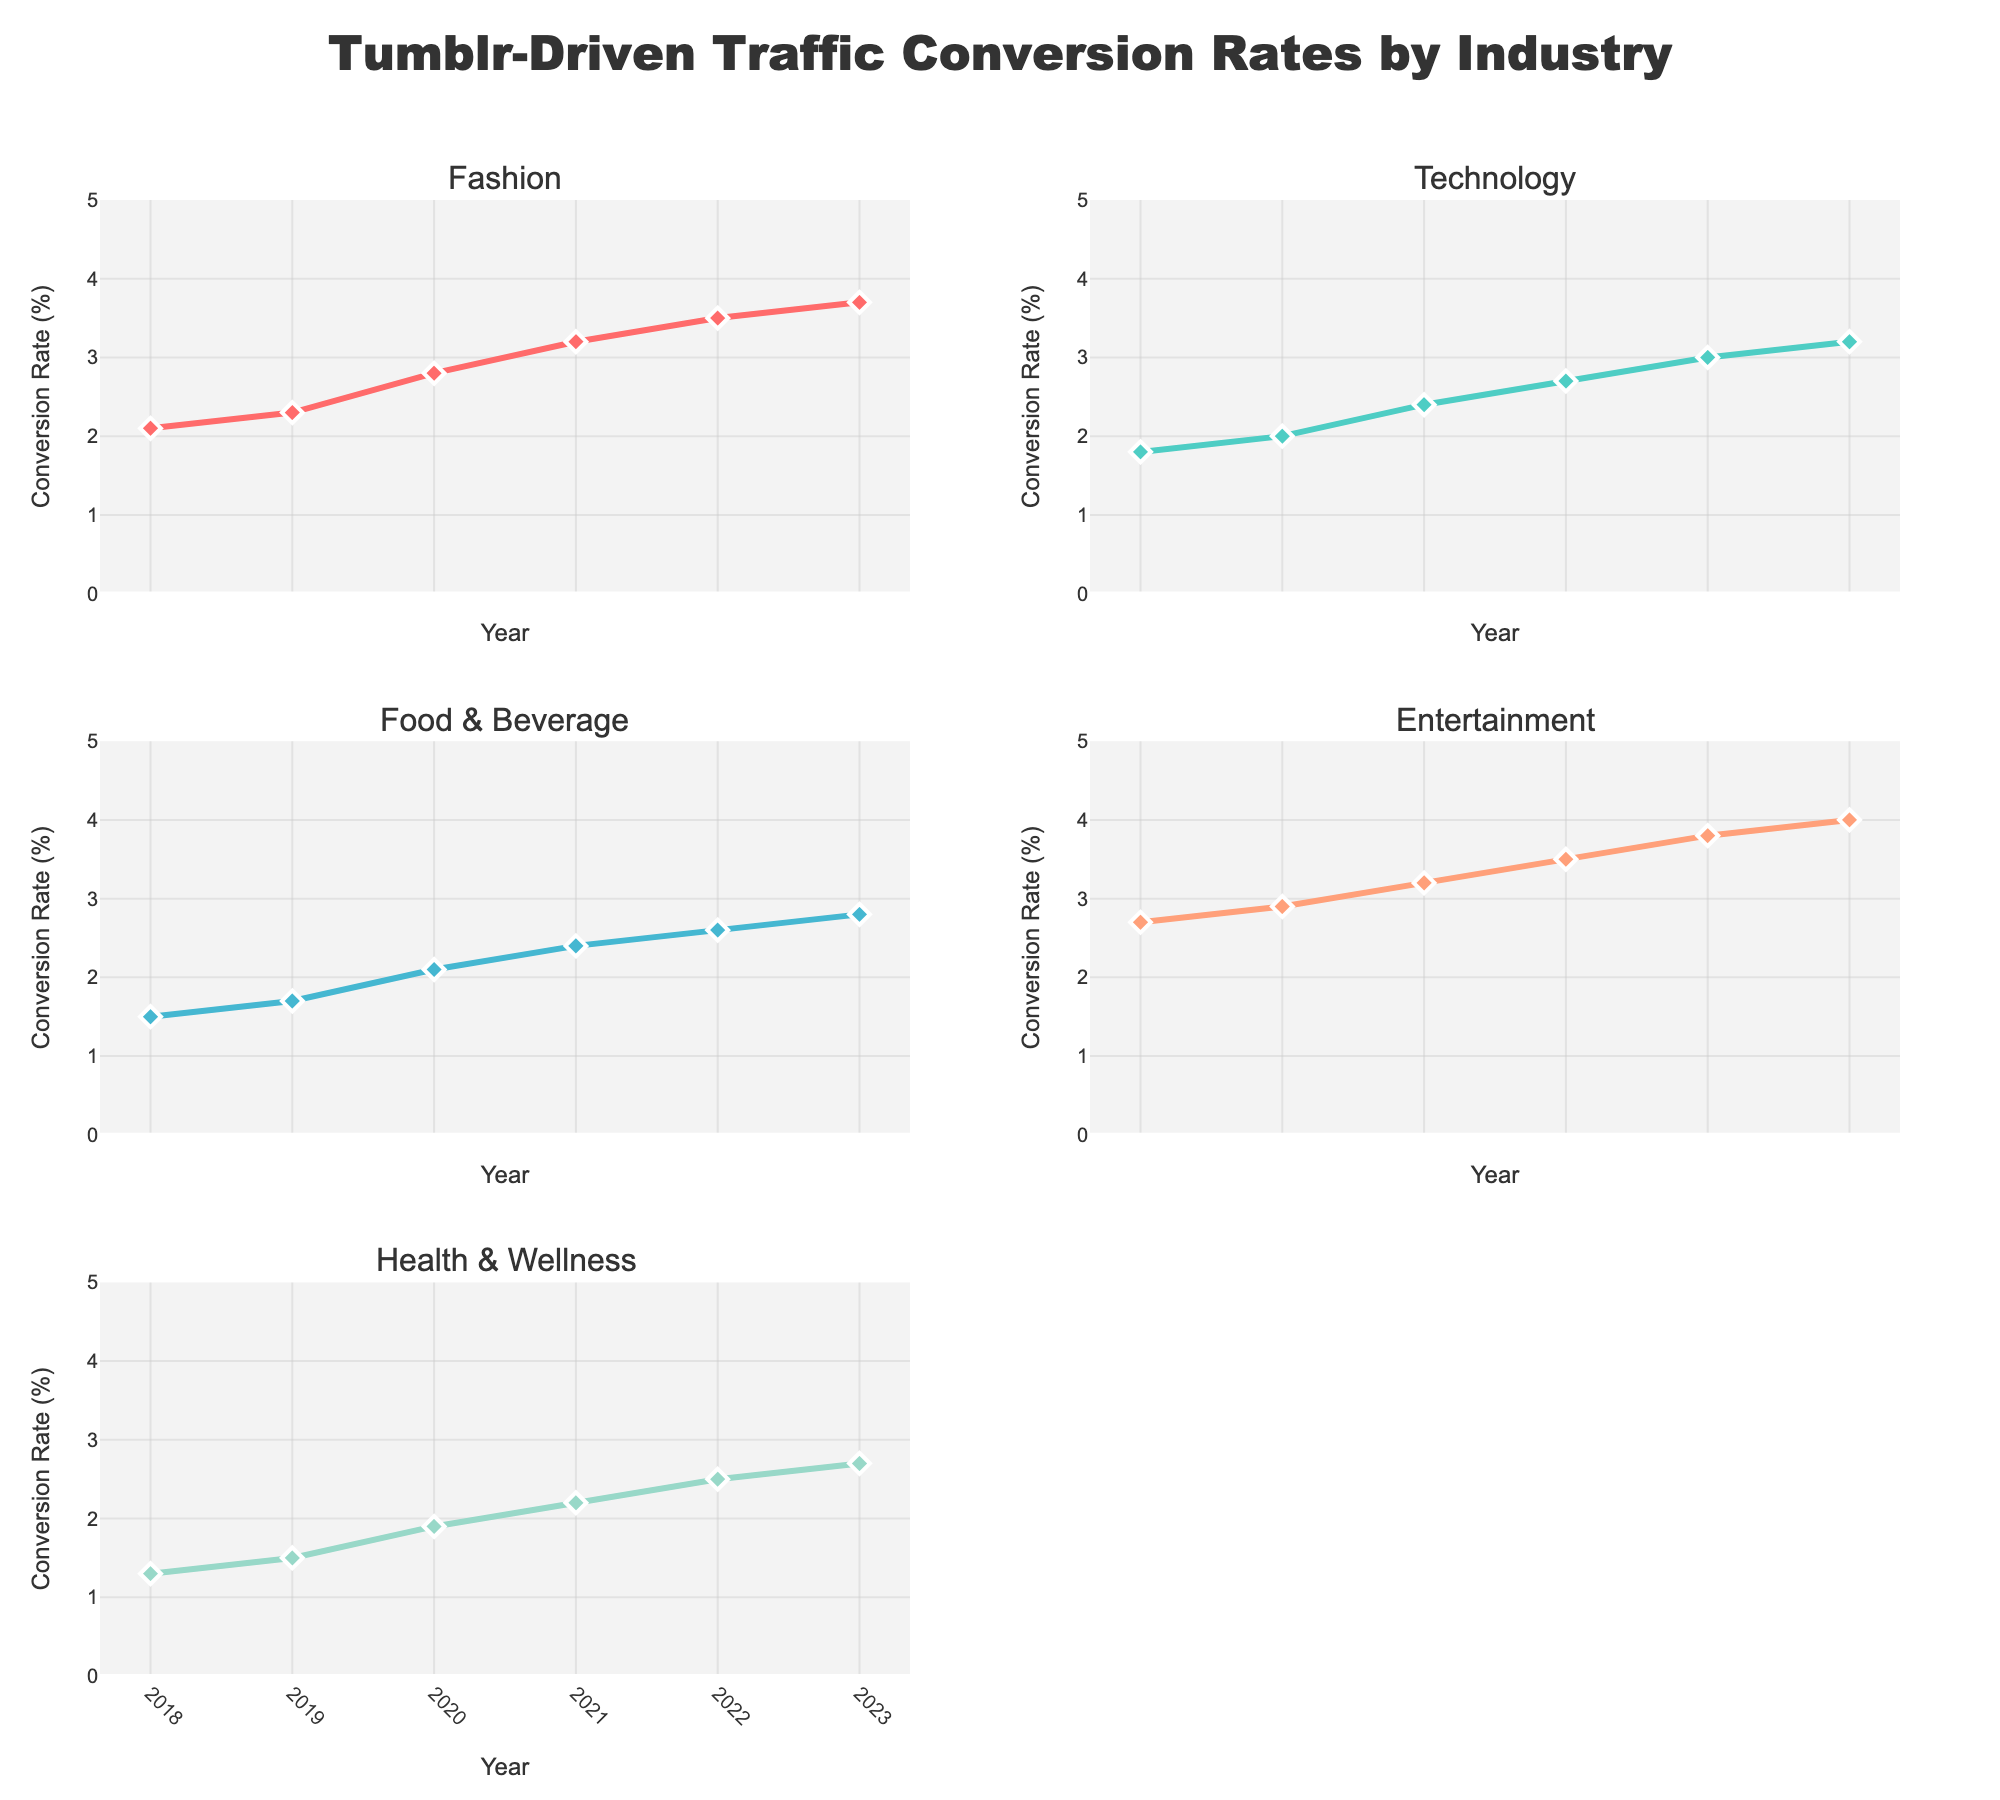How many industries are represented in the figure? The figure shows five subplots, each corresponding to a different industry.
Answer: Five What is the title of the figure? The title is centrally placed at the top of the figure and reads "Tumblr-Driven Traffic Conversion Rates by Industry".
Answer: Tumblr-Driven Traffic Conversion Rates by Industry Which industry had the highest conversion rate in 2023? Within each subplot, the conversion rate for each industry in 2023 is indicated by the line markers. The "Entertainment" industry subplot shows the highest conversion rate in 2023 at 4.0%.
Answer: Entertainment Between which years did the Technology industry see the greatest increase in conversion rate? To find the greatest increase, look at the differences in conversion rates between consecutive years. The increase was the largest between 2019 (2.0%) and 2020 (2.4%), resulting in an increase of 0.4%.
Answer: 2019 and 2020 What was the conversion rate for the Health & Wellness industry in 2022? The subplot for "Health & Wellness" shows the markers for different years; the marker for 2022 indicates a conversion rate of 2.5%.
Answer: 2.5% Which year showed the largest overall increase in conversion rates across all industries? Determine the yearly increases for each industry and sum them up. 2020 has the highest summed increase: (2.8-2.3) + (2.4-2.0) + (2.1-1.7) + (3.2-2.9) + (1.9-1.5) = 0.5+0.4+0.4+0.3+0.4 = 2.0.
Answer: 2020 Did any industry have a conversion rate lower than 1.5% at any time? Looking at the lowest conversion markers across the subplots, all industries had conversion rates above 1.5% for all years shown.
Answer: No From 2018 to 2023, which industry had the smallest growth in conversion rates? Calculate the difference between 2023 and 2018 conversion rates for each industry. Health & Wellness grew from 1.3% to 2.7%, which is an increase of 1.4, smallest compared to other industries.
Answer: Health & Wellness 